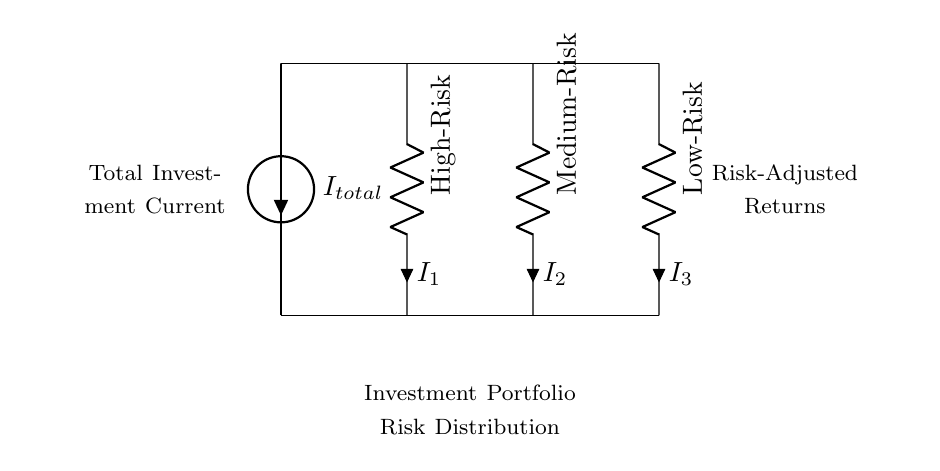What is the total current in the circuit? The total current is represented by the source labeled as I_total. It is the sum of the currents flowing through all paths in the current divider.
Answer: I_total What are the resistance values in this circuit? The circuit has three resistors: R_1 (High-Risk), R_2 (Medium-Risk), and R_3 (Low-Risk). Each represents a different risk category associated with the investment.
Answer: R_1, R_2, R_3 Which resistor has the highest risk associated with it? The resistor labeled R_1 is associated with High-Risk investments. It reflects a higher potential return but also entails more risk.
Answer: R_1 What can be inferred about the current distribution among the resistors? The total current I_total divides among the resistors based on their resistance values, whereby lower resistance leads to higher current and vice versa. The relationship stems from the basics of a current divider, where total current is inversely proportional to resistance.
Answer: Current distribution How does the current divide among R_1, R_2, and R_3? In a current divider, the current through each resistor is inversely proportional to its resistance. Therefore, if R_1 has the lowest resistance, it will carry the most current, while the highest resistance (R_3) will carry the least current. This shows the risk-return tradeoff in investments.
Answer: Inversely proportional 